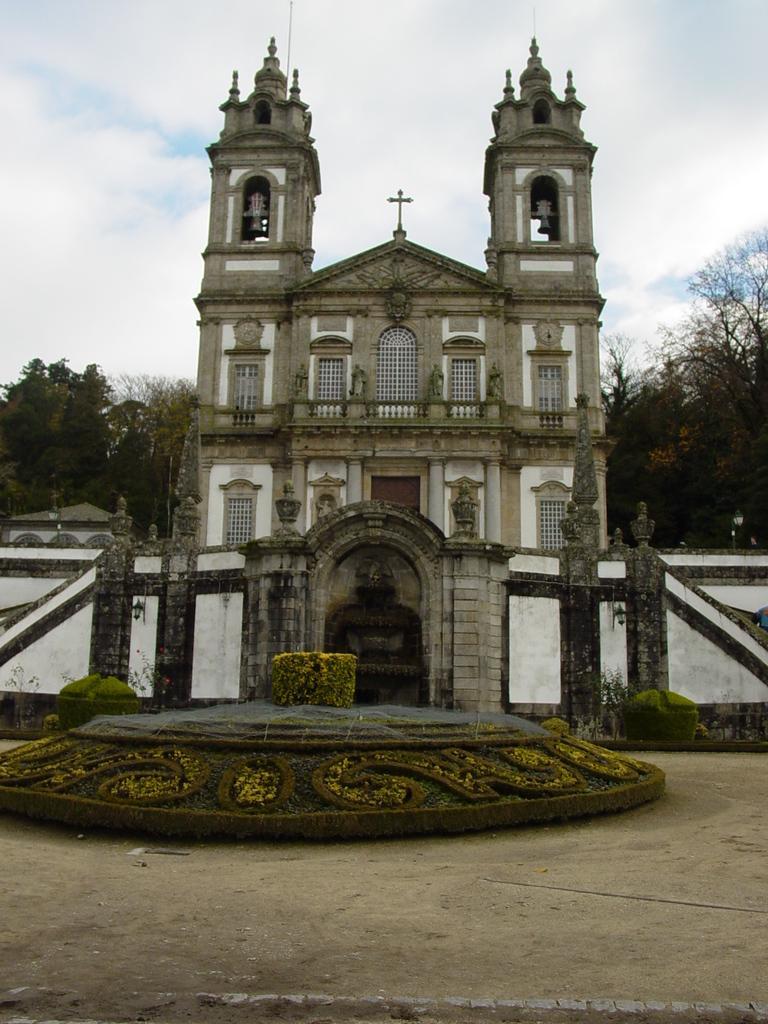Can you describe this image briefly? I think this is the church with windows and doors. These are the sculptures. I can see a holy cross symbol and the bells at the top of the church. These are the trees. I think this is the compound wall. I can see the small bushes. 